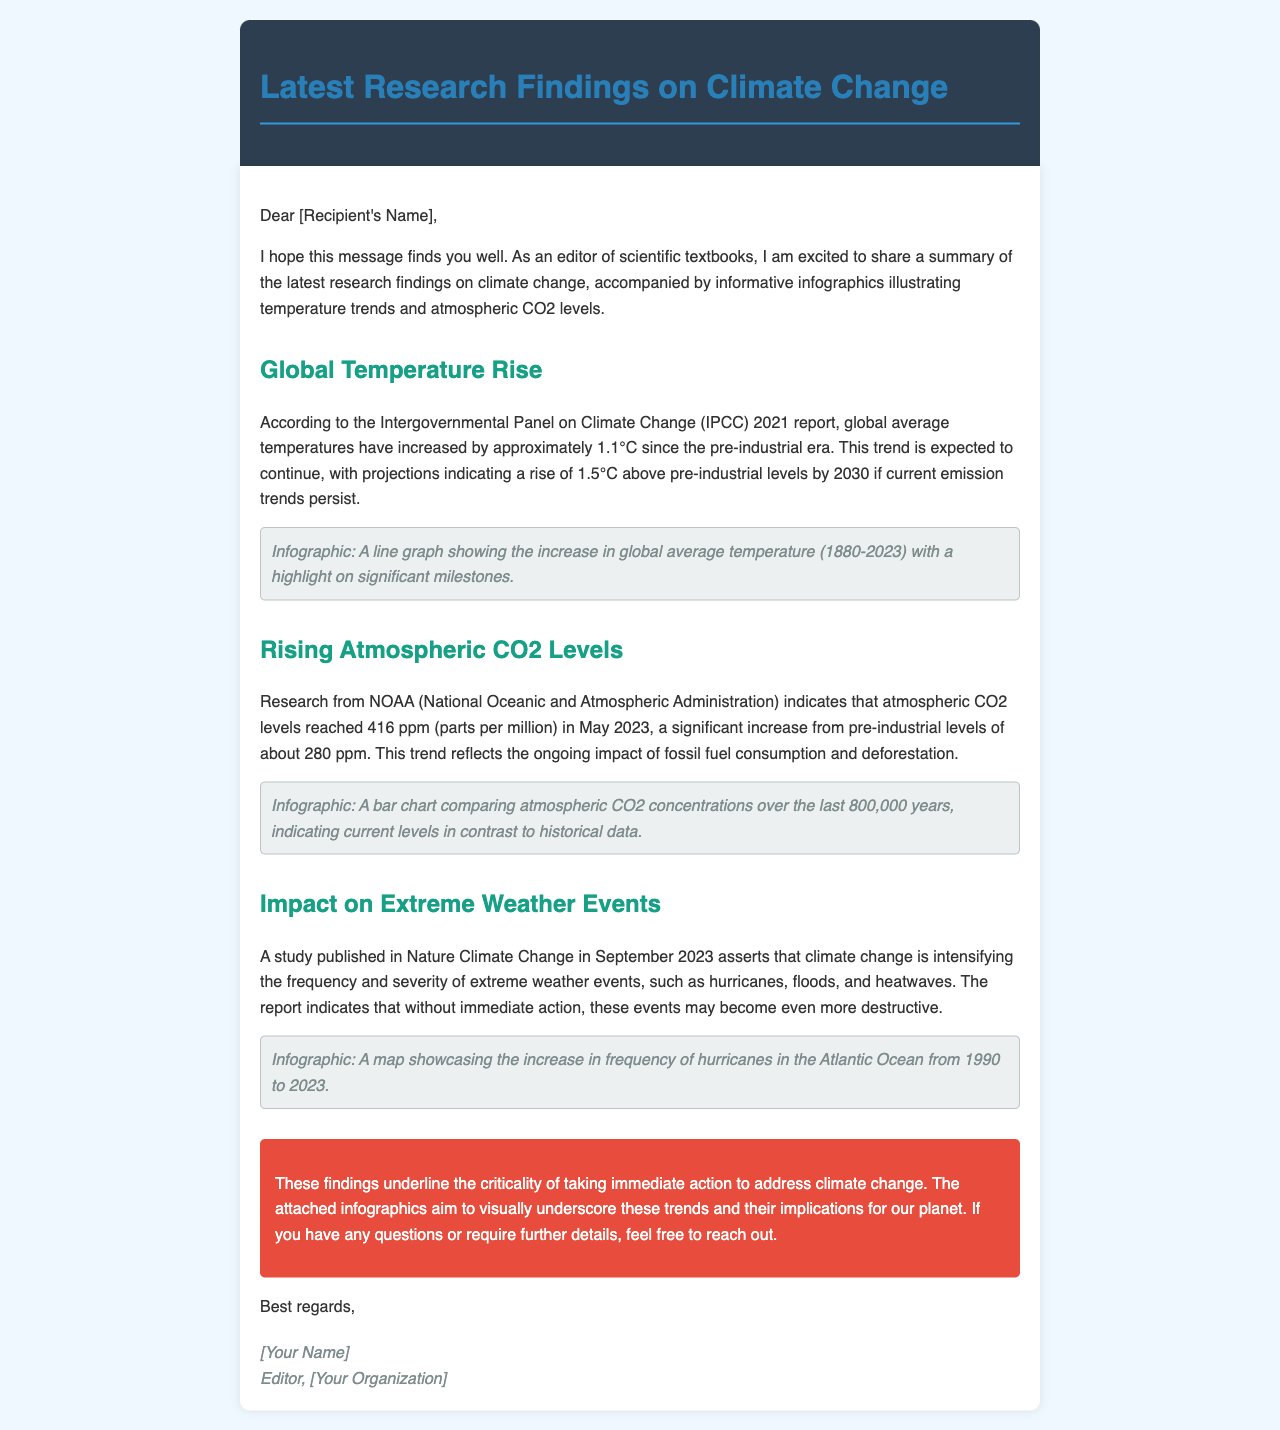What is the global average temperature increase since the pre-industrial era? The document states that global average temperatures have increased by approximately 1.1°C since the pre-industrial era.
Answer: 1.1°C What is the projected temperature rise by 2030 if current emission trends persist? The projection indicates a rise of 1.5°C above pre-industrial levels by 2030.
Answer: 1.5°C What was the atmospheric CO2 level in May 2023? According to the NOAA research mentioned, atmospheric CO2 levels reached 416 ppm in May 2023.
Answer: 416 ppm What were the pre-industrial atmospheric CO2 levels? The document reveals that pre-industrial levels of CO2 were about 280 ppm.
Answer: 280 ppm Which organization published the study on extreme weather events? The study on extreme weather events was published in Nature Climate Change.
Answer: Nature Climate Change What trend does the infographic of CO2 concentrations depict? The infographic indicates atmospheric CO2 concentrations over the last 800,000 years in contrast to current levels.
Answer: CO2 concentrations What is the time frame for the increase in frequency of hurricanes shown in the infographic? The infographic showing hurricane frequency covers the period from 1990 to 2023.
Answer: 1990 to 2023 What action is emphasized in the conclusion regarding climate change? The conclusion underscores the criticality of taking immediate action to address climate change.
Answer: Immediate action Who is the sender of the email? The email is signed by [Your Name], who is the editor.
Answer: [Your Name] 